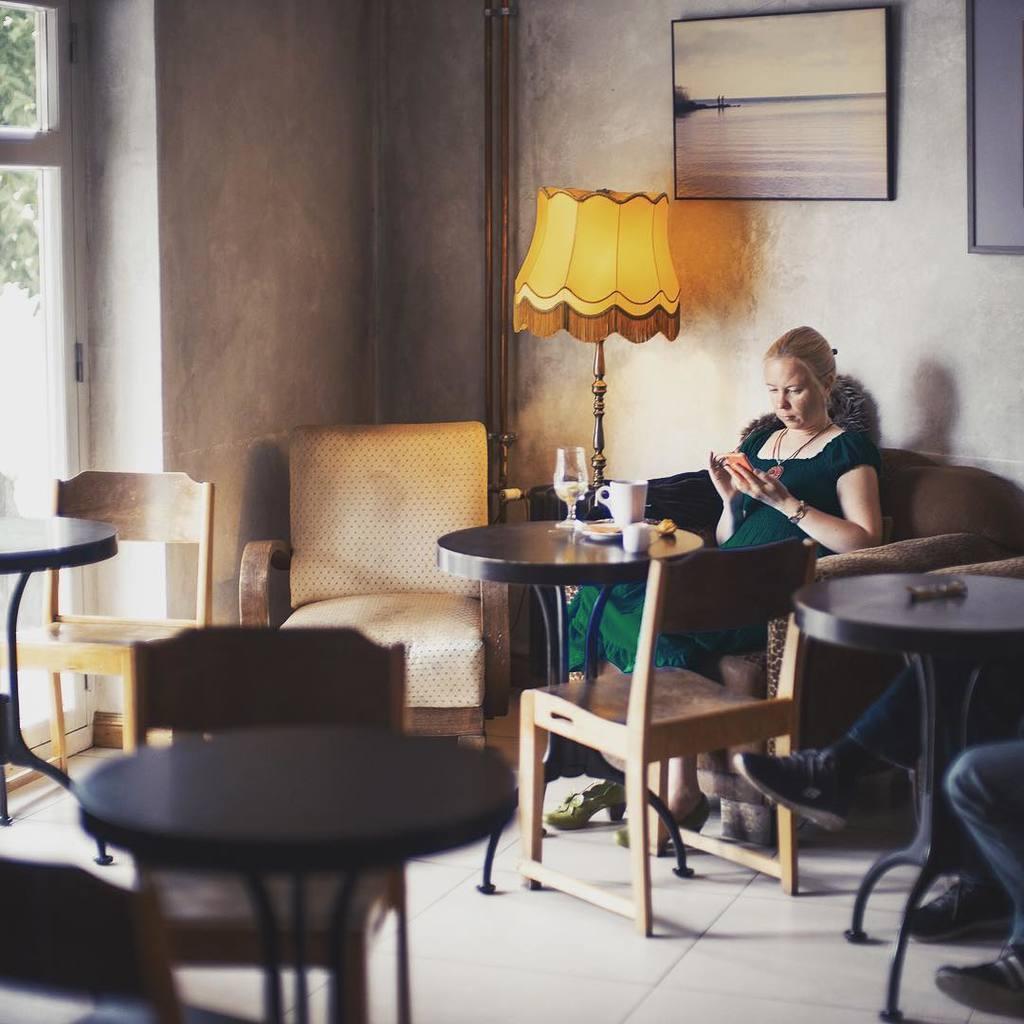Please provide a concise description of this image. This picture describe about the woman who is sitting on the sofa and seeing in the mobile phone, in front she has a round wooden table on which cup of coffee and food is placed. And a big table light beside her and behind there is a wall on which photo frame is a place and a relaxing chair and a big glass window from which trees are seen. 